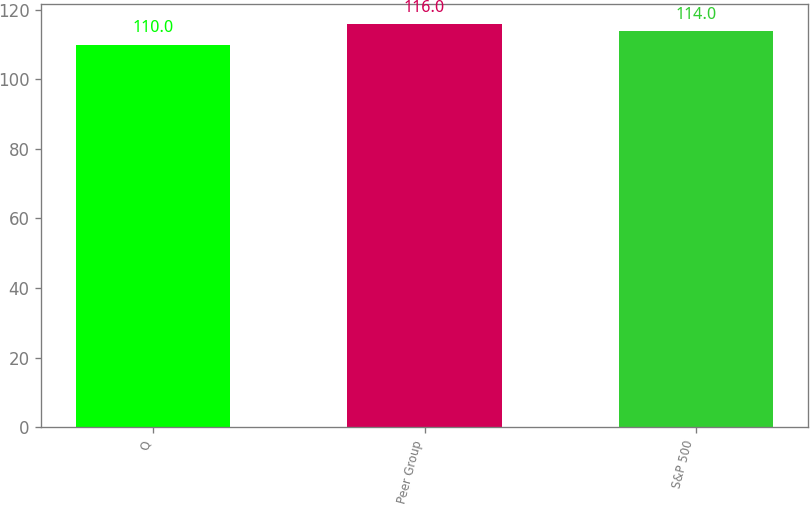Convert chart. <chart><loc_0><loc_0><loc_500><loc_500><bar_chart><fcel>Q<fcel>Peer Group<fcel>S&P 500<nl><fcel>110<fcel>116<fcel>114<nl></chart> 